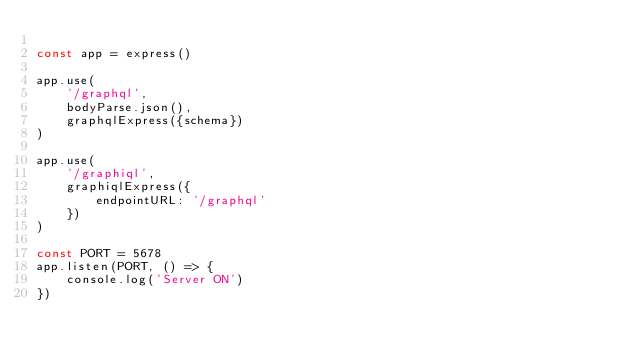Convert code to text. <code><loc_0><loc_0><loc_500><loc_500><_JavaScript_>
const app = express()

app.use(
    '/graphql',
    bodyParse.json(), 
    graphqlExpress({schema})
)

app.use(
    '/graphiql',
    graphiqlExpress({
        endpointURL: '/graphql'
    })
)

const PORT = 5678
app.listen(PORT, () => {
    console.log('Server ON')
})</code> 